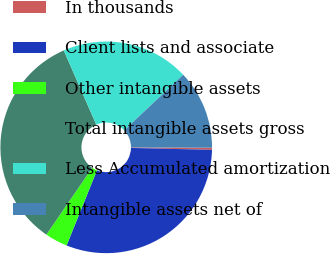Convert chart to OTSL. <chart><loc_0><loc_0><loc_500><loc_500><pie_chart><fcel>In thousands<fcel>Client lists and associate<fcel>Other intangible assets<fcel>Total intangible assets gross<fcel>Less Accumulated amortization<fcel>Intangible assets net of<nl><fcel>0.32%<fcel>30.74%<fcel>3.45%<fcel>33.87%<fcel>19.54%<fcel>12.09%<nl></chart> 